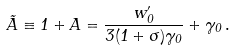<formula> <loc_0><loc_0><loc_500><loc_500>\tilde { A } \equiv 1 + A = \frac { w _ { 0 } ^ { \prime } } { 3 ( 1 + \sigma ) \gamma _ { 0 } } + \gamma _ { 0 } \, .</formula> 